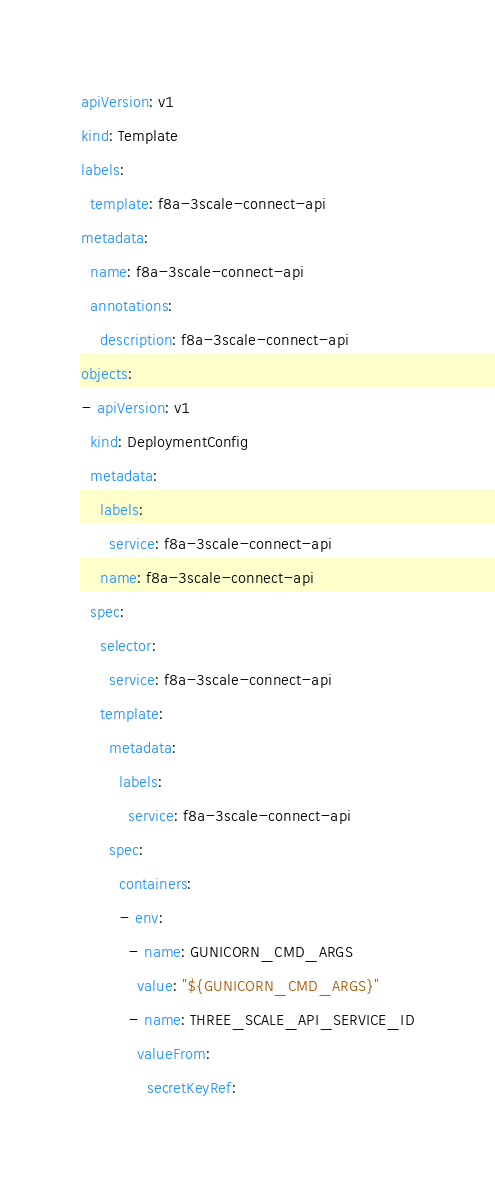<code> <loc_0><loc_0><loc_500><loc_500><_YAML_>apiVersion: v1
kind: Template
labels:
  template: f8a-3scale-connect-api
metadata:
  name: f8a-3scale-connect-api
  annotations:
    description: f8a-3scale-connect-api
objects:
- apiVersion: v1
  kind: DeploymentConfig
  metadata:
    labels:
      service: f8a-3scale-connect-api
    name: f8a-3scale-connect-api
  spec:
    selector:
      service: f8a-3scale-connect-api
    template:
      metadata:
        labels:
          service: f8a-3scale-connect-api
      spec:
        containers:
        - env:
          - name: GUNICORN_CMD_ARGS
            value: "${GUNICORN_CMD_ARGS}"
          - name: THREE_SCALE_API_SERVICE_ID
            valueFrom:
              secretKeyRef:</code> 